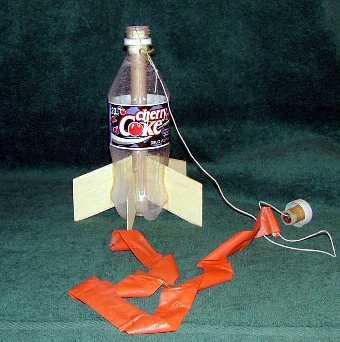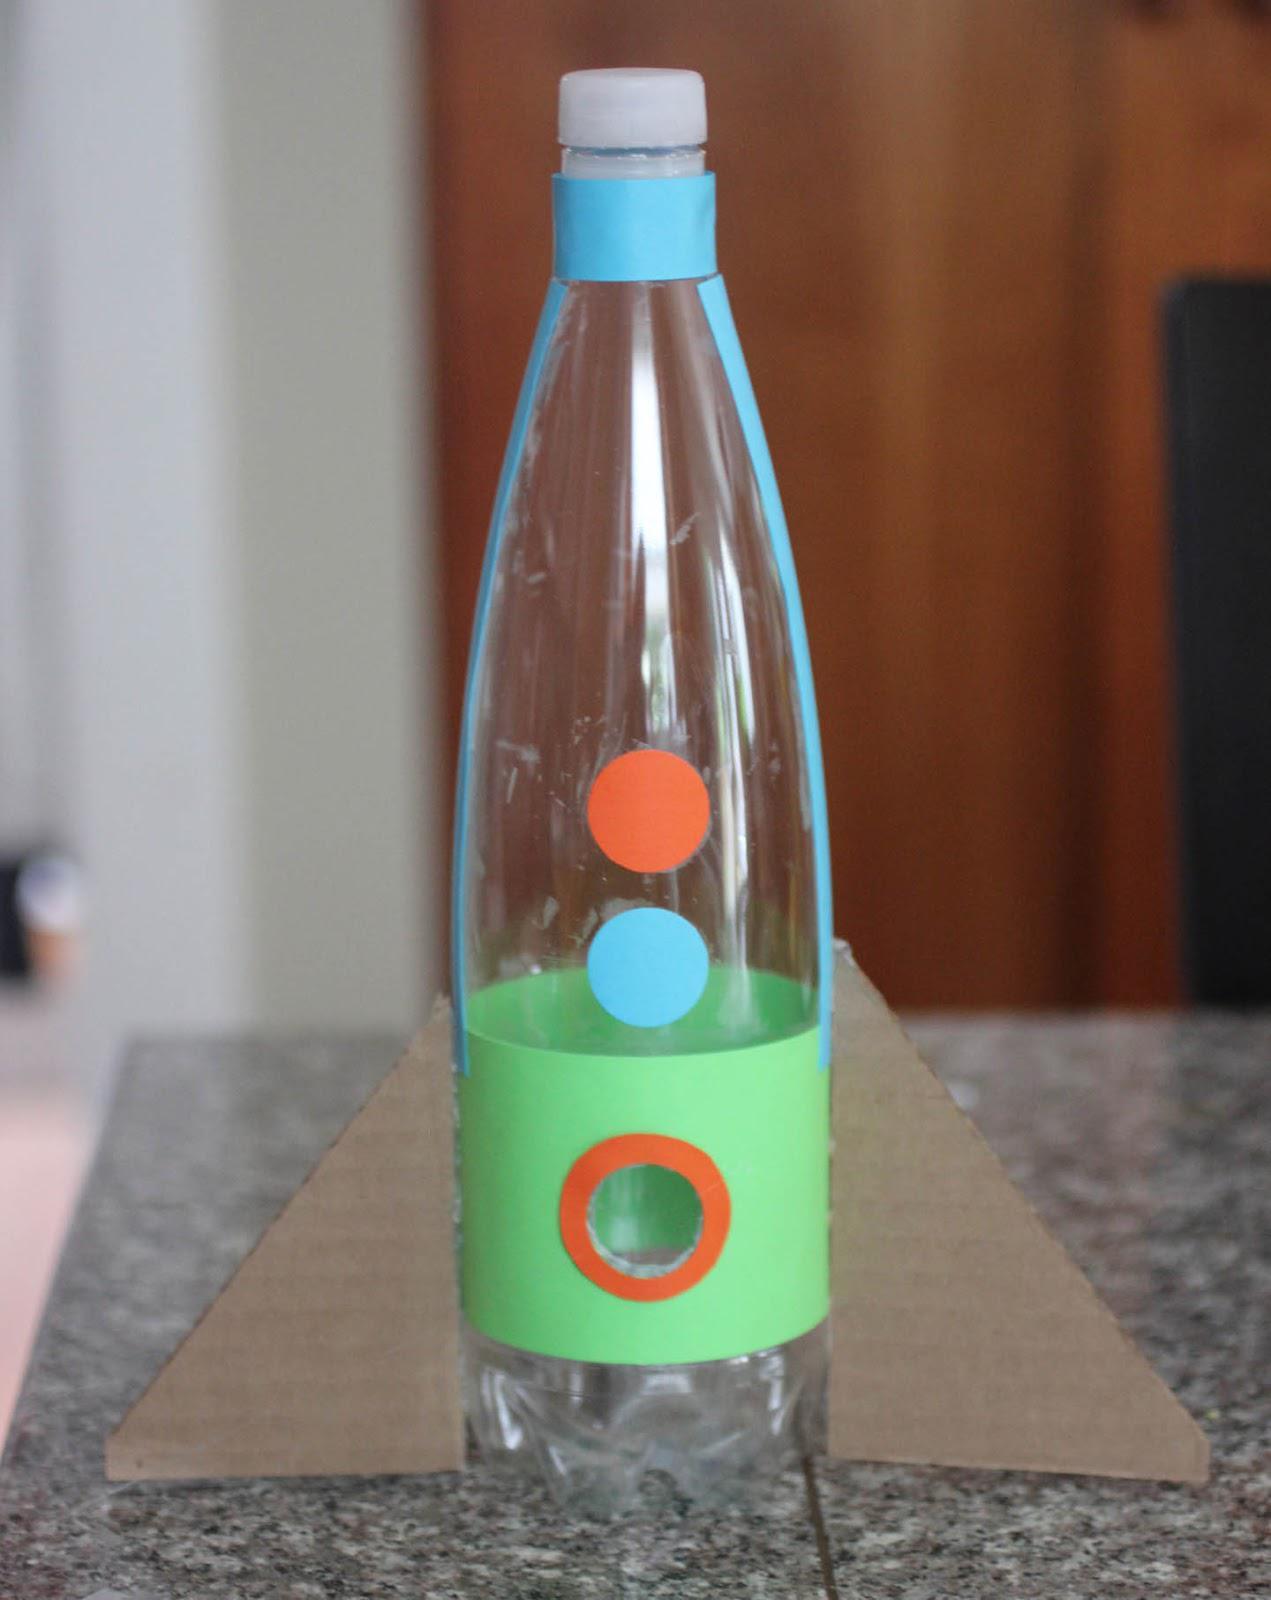The first image is the image on the left, the second image is the image on the right. Given the left and right images, does the statement "The left image features one inverted bottle with fins on its base to create a rocket ship." hold true? Answer yes or no. No. The first image is the image on the left, the second image is the image on the right. Analyze the images presented: Is the assertion "A person is holding the bottle rocket in one of the images." valid? Answer yes or no. No. 